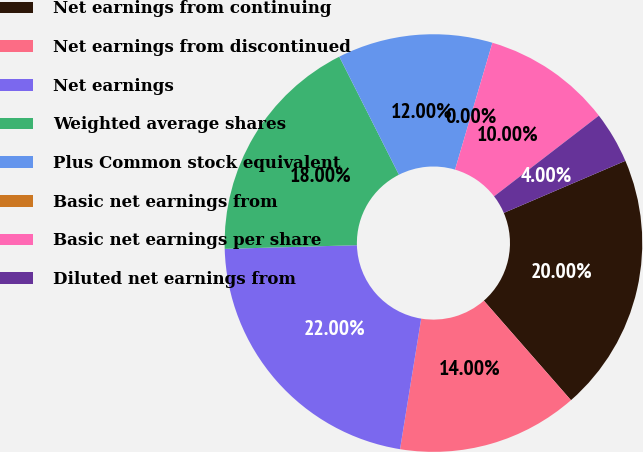Convert chart. <chart><loc_0><loc_0><loc_500><loc_500><pie_chart><fcel>Net earnings from continuing<fcel>Net earnings from discontinued<fcel>Net earnings<fcel>Weighted average shares<fcel>Plus Common stock equivalent<fcel>Basic net earnings from<fcel>Basic net earnings per share<fcel>Diluted net earnings from<nl><fcel>20.0%<fcel>14.0%<fcel>22.0%<fcel>18.0%<fcel>12.0%<fcel>0.0%<fcel>10.0%<fcel>4.0%<nl></chart> 